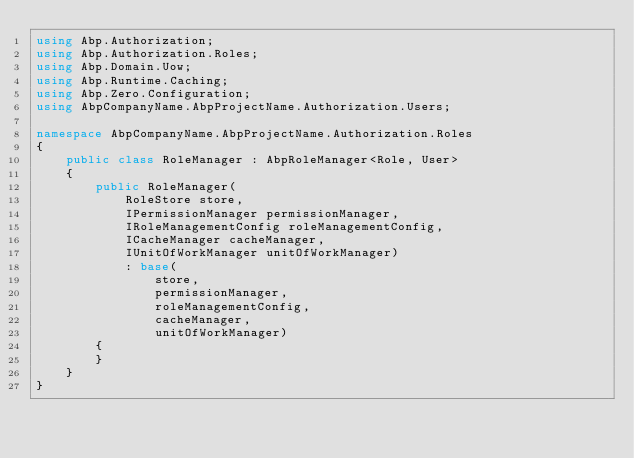<code> <loc_0><loc_0><loc_500><loc_500><_C#_>using Abp.Authorization;
using Abp.Authorization.Roles;
using Abp.Domain.Uow;
using Abp.Runtime.Caching;
using Abp.Zero.Configuration;
using AbpCompanyName.AbpProjectName.Authorization.Users;

namespace AbpCompanyName.AbpProjectName.Authorization.Roles
{
    public class RoleManager : AbpRoleManager<Role, User>
    {
        public RoleManager(
            RoleStore store,
            IPermissionManager permissionManager,
            IRoleManagementConfig roleManagementConfig,
            ICacheManager cacheManager,
            IUnitOfWorkManager unitOfWorkManager)
            : base(
                store,
                permissionManager,
                roleManagementConfig,
                cacheManager,
                unitOfWorkManager)
        {
        }
    }
}</code> 